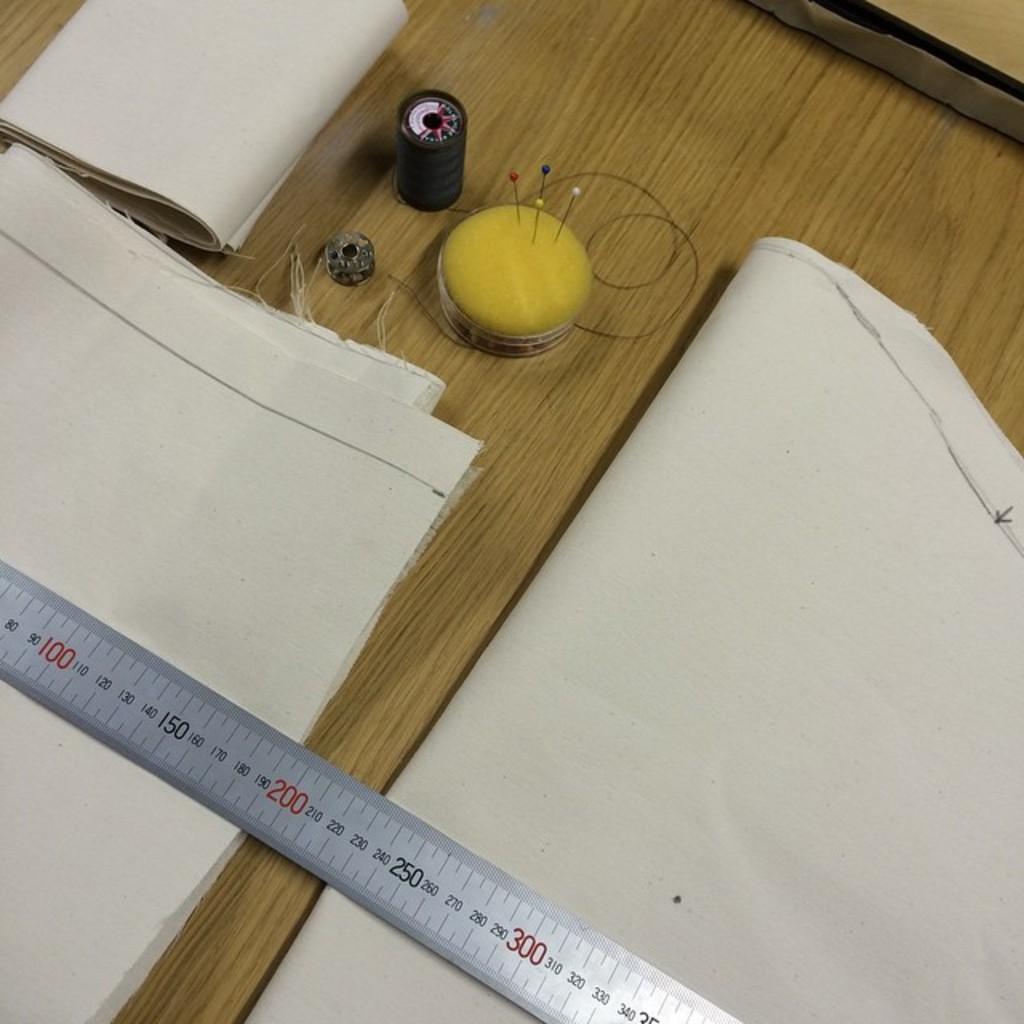What width is the first piece of cloth?
Provide a succinct answer. 190. What 3 numbers are listed in red?
Ensure brevity in your answer.  100, 200, 300. 